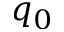Convert formula to latex. <formula><loc_0><loc_0><loc_500><loc_500>q _ { 0 }</formula> 